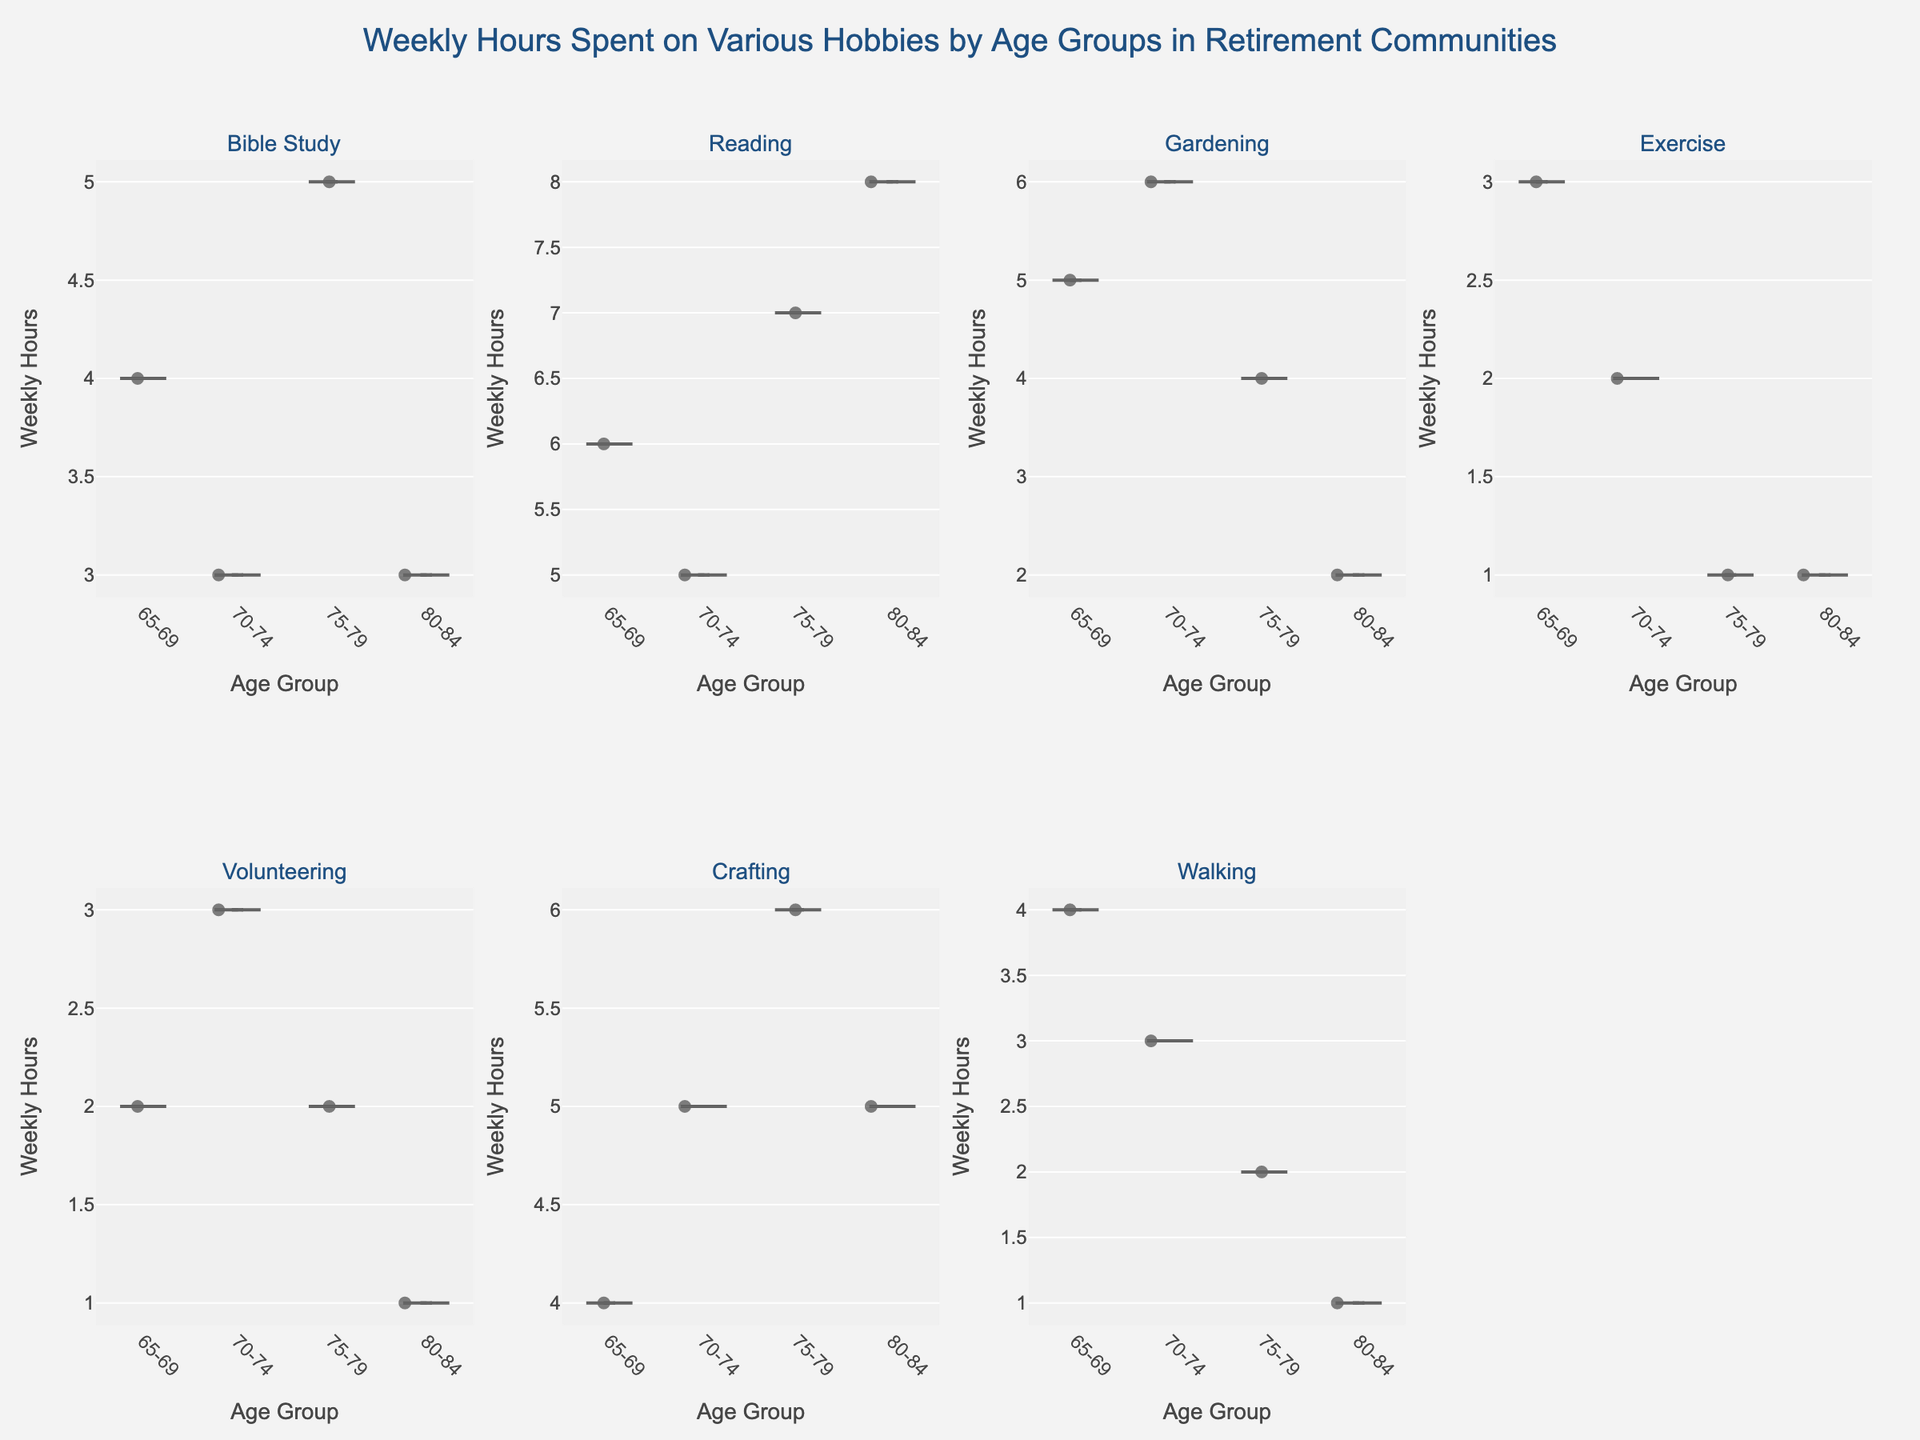What's the title of the figure? The title of the plot is prominently displayed at the top center of the figure in a larger font size. It reads: "Weekly Hours Spent on Various Hobbies by Age Groups in Retirement Communities".
Answer: Weekly Hours Spent on Various Hobbies by Age Groups in Retirement Communities What are the age groups shown in the figure? The age groups are listed on the x-axis of each subplot. They include: 65-69, 70-74, 75-79, and 80-84.
Answer: 65-69, 70-74, 75-79, 80-84 Which hobby has the highest average weekly hours among the age groups? By observing the meanlines in each subplot, it is evident that "Reading" has the violin plot with the highest average weekly hours, particularly noticeable in the 80-84 age group.
Answer: Reading Which hobby appears to be the least time-intensive across all age groups? By comparing the widths and positions of the violins, "Exercise" has the lowest average weekly hours across all age groups, with many individuals spending only 1-2 hours per week.
Answer: Exercise How does the weekly hours spent on Bible Study change with age? By examining the subplot for "Bible Study", it seems that the hours increase slightly and then decrease. 65-69: 4 hours, 70-74: 3 hours, 75-79: 5 hours, 80-84: 3 hours.
Answer: Increase, then decrease Which hobby shows the most variation in weekly hours among the 70-74 age group? By examining the spread of the violin plots for the 70-74 age group, "Gardening" shows the widest distribution, indicating the greatest variation.
Answer: Gardening What is the primary color used in the violin plot for Crafting? It's easy to identify the primary color by looking at the Crafting subplot; it appears to be a light purple.
Answer: Light purple Which hobby has the highest weekly hours recorded and in which age group? By examining the distribution of points within the violins, "Reading" for the 80-84 age group shows the highest weekly hours, with some individuals recording up to 8 hours.
Answer: Reading, 80-84 Are there any hobbies where the time spent decreases consistently with age? By following the trend across age groups, "Exercise" shows a consistent decrease in the weekly hours spent from 3 hours in 65-69 to 1 hour in 80-84.
Answer: Exercise 